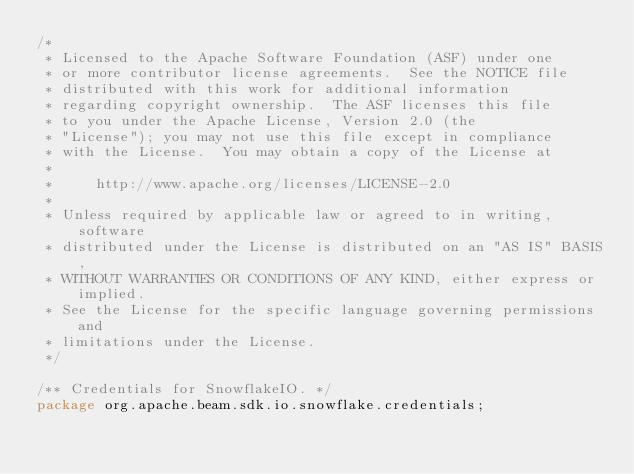<code> <loc_0><loc_0><loc_500><loc_500><_Java_>/*
 * Licensed to the Apache Software Foundation (ASF) under one
 * or more contributor license agreements.  See the NOTICE file
 * distributed with this work for additional information
 * regarding copyright ownership.  The ASF licenses this file
 * to you under the Apache License, Version 2.0 (the
 * "License"); you may not use this file except in compliance
 * with the License.  You may obtain a copy of the License at
 *
 *     http://www.apache.org/licenses/LICENSE-2.0
 *
 * Unless required by applicable law or agreed to in writing, software
 * distributed under the License is distributed on an "AS IS" BASIS,
 * WITHOUT WARRANTIES OR CONDITIONS OF ANY KIND, either express or implied.
 * See the License for the specific language governing permissions and
 * limitations under the License.
 */

/** Credentials for SnowflakeIO. */
package org.apache.beam.sdk.io.snowflake.credentials;
</code> 